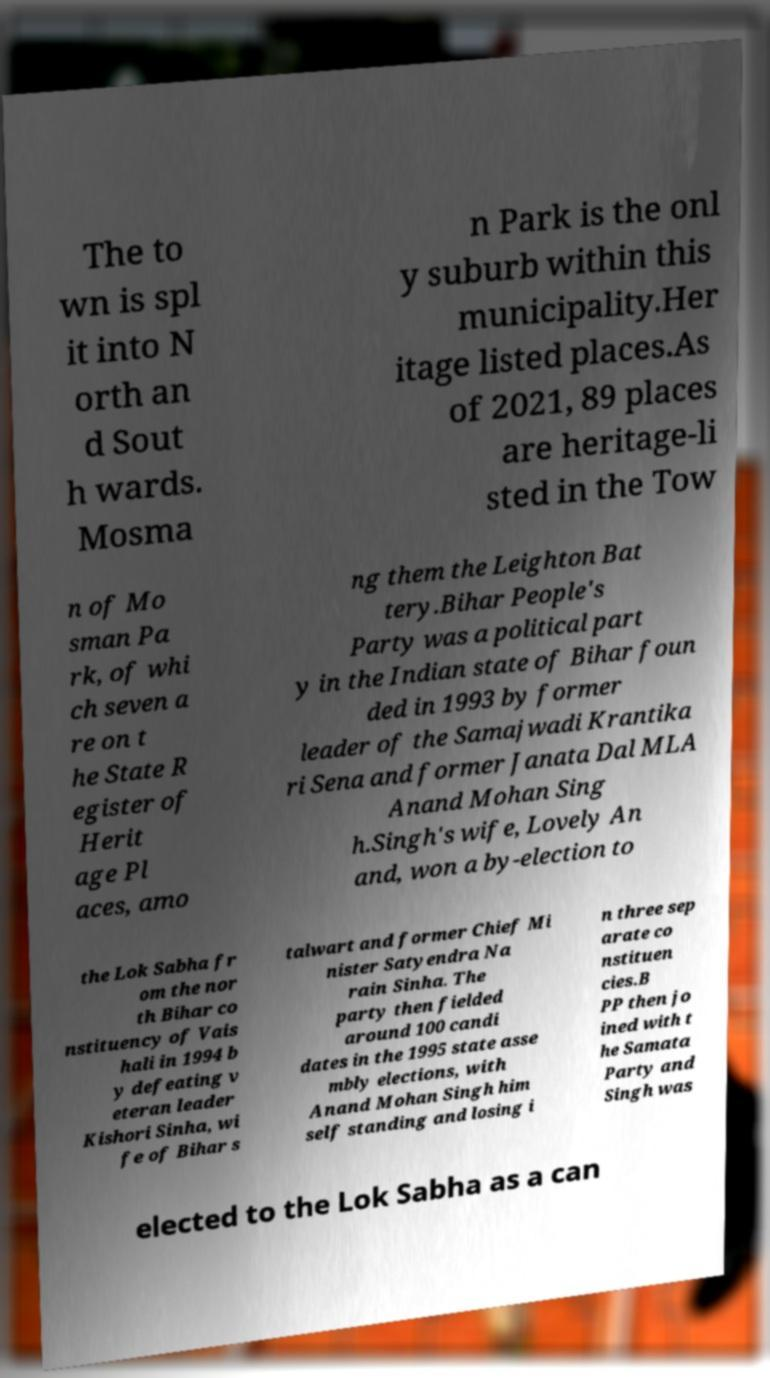There's text embedded in this image that I need extracted. Can you transcribe it verbatim? The to wn is spl it into N orth an d Sout h wards. Mosma n Park is the onl y suburb within this municipality.Her itage listed places.As of 2021, 89 places are heritage-li sted in the Tow n of Mo sman Pa rk, of whi ch seven a re on t he State R egister of Herit age Pl aces, amo ng them the Leighton Bat tery.Bihar People's Party was a political part y in the Indian state of Bihar foun ded in 1993 by former leader of the Samajwadi Krantika ri Sena and former Janata Dal MLA Anand Mohan Sing h.Singh's wife, Lovely An and, won a by-election to the Lok Sabha fr om the nor th Bihar co nstituency of Vais hali in 1994 b y defeating v eteran leader Kishori Sinha, wi fe of Bihar s talwart and former Chief Mi nister Satyendra Na rain Sinha. The party then fielded around 100 candi dates in the 1995 state asse mbly elections, with Anand Mohan Singh him self standing and losing i n three sep arate co nstituen cies.B PP then jo ined with t he Samata Party and Singh was elected to the Lok Sabha as a can 